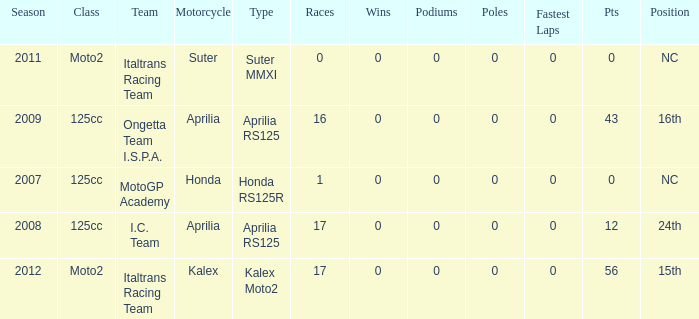What's Italtrans Racing Team's, with 0 pts, class? Moto2. 